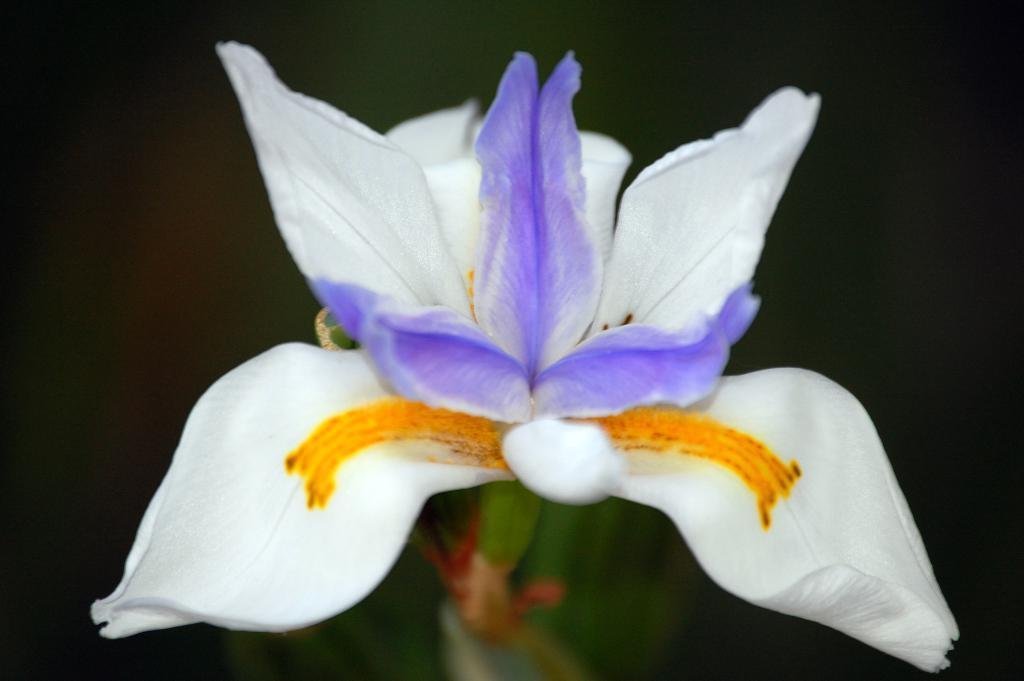In one or two sentences, can you explain what this image depicts? In this image, we can see a flower. Background we can see the blur view. At the bottom, where it looks like stems. 